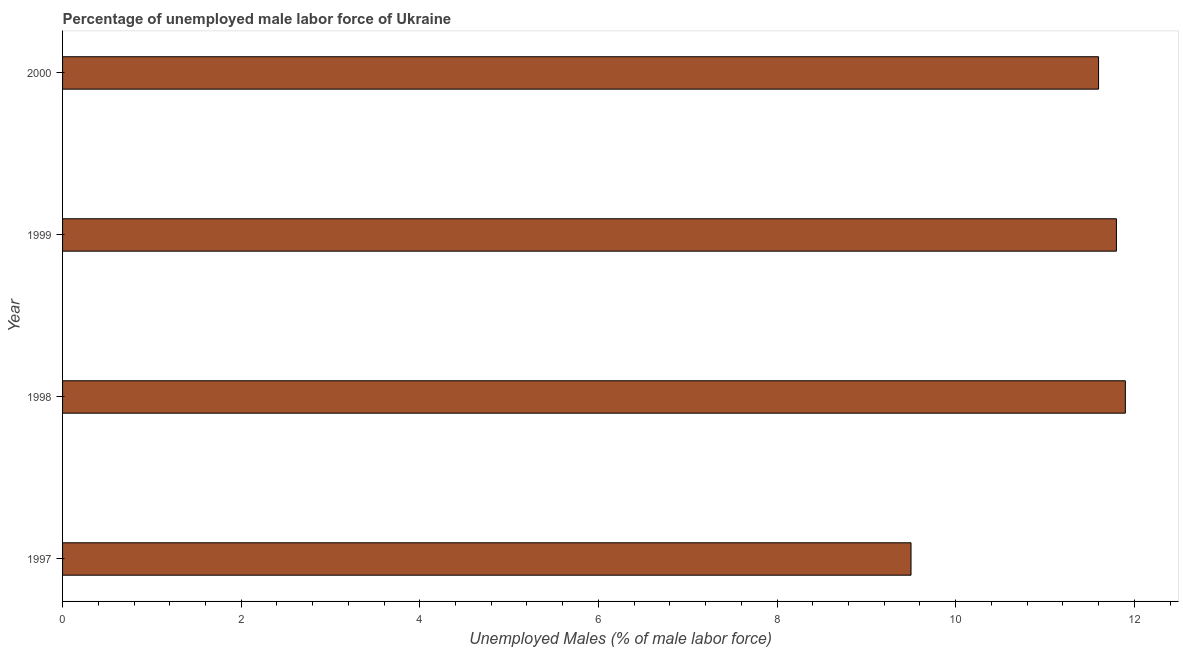Does the graph contain grids?
Offer a terse response. No. What is the title of the graph?
Offer a very short reply. Percentage of unemployed male labor force of Ukraine. What is the label or title of the X-axis?
Your response must be concise. Unemployed Males (% of male labor force). What is the label or title of the Y-axis?
Your response must be concise. Year. What is the total unemployed male labour force in 1998?
Your answer should be compact. 11.9. Across all years, what is the maximum total unemployed male labour force?
Give a very brief answer. 11.9. In which year was the total unemployed male labour force maximum?
Make the answer very short. 1998. What is the sum of the total unemployed male labour force?
Offer a very short reply. 44.8. What is the difference between the total unemployed male labour force in 1998 and 1999?
Make the answer very short. 0.1. What is the median total unemployed male labour force?
Ensure brevity in your answer.  11.7. Do a majority of the years between 1998 and 1997 (inclusive) have total unemployed male labour force greater than 6.4 %?
Give a very brief answer. No. What is the ratio of the total unemployed male labour force in 1998 to that in 1999?
Provide a short and direct response. 1.01. What is the difference between the highest and the second highest total unemployed male labour force?
Ensure brevity in your answer.  0.1. Is the sum of the total unemployed male labour force in 1998 and 1999 greater than the maximum total unemployed male labour force across all years?
Keep it short and to the point. Yes. What is the difference between the highest and the lowest total unemployed male labour force?
Offer a very short reply. 2.4. In how many years, is the total unemployed male labour force greater than the average total unemployed male labour force taken over all years?
Your response must be concise. 3. How many bars are there?
Your answer should be very brief. 4. Are all the bars in the graph horizontal?
Provide a short and direct response. Yes. What is the difference between two consecutive major ticks on the X-axis?
Keep it short and to the point. 2. What is the Unemployed Males (% of male labor force) of 1997?
Make the answer very short. 9.5. What is the Unemployed Males (% of male labor force) in 1998?
Provide a short and direct response. 11.9. What is the Unemployed Males (% of male labor force) in 1999?
Provide a short and direct response. 11.8. What is the Unemployed Males (% of male labor force) of 2000?
Give a very brief answer. 11.6. What is the difference between the Unemployed Males (% of male labor force) in 1997 and 1998?
Your answer should be compact. -2.4. What is the difference between the Unemployed Males (% of male labor force) in 1998 and 1999?
Give a very brief answer. 0.1. What is the difference between the Unemployed Males (% of male labor force) in 1999 and 2000?
Your answer should be compact. 0.2. What is the ratio of the Unemployed Males (% of male labor force) in 1997 to that in 1998?
Offer a terse response. 0.8. What is the ratio of the Unemployed Males (% of male labor force) in 1997 to that in 1999?
Keep it short and to the point. 0.81. What is the ratio of the Unemployed Males (% of male labor force) in 1997 to that in 2000?
Keep it short and to the point. 0.82. 